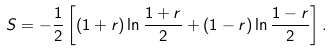Convert formula to latex. <formula><loc_0><loc_0><loc_500><loc_500>S = - \frac { 1 } { 2 } \left [ ( 1 + r ) \ln \frac { 1 + r } { 2 } + ( 1 - r ) \ln \frac { 1 - r } { 2 } \right ] .</formula> 